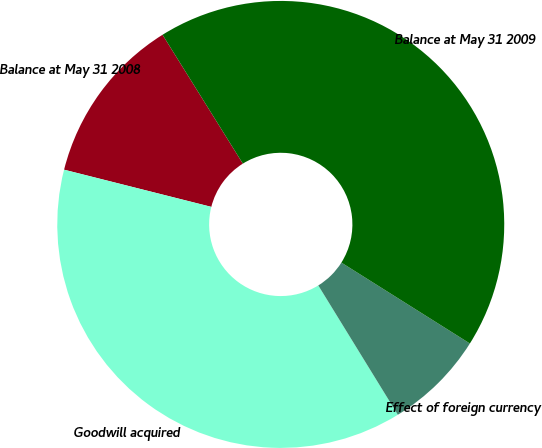Convert chart. <chart><loc_0><loc_0><loc_500><loc_500><pie_chart><fcel>Balance at May 31 2008<fcel>Goodwill acquired<fcel>Effect of foreign currency<fcel>Balance at May 31 2009<nl><fcel>12.19%<fcel>37.71%<fcel>7.28%<fcel>42.81%<nl></chart> 